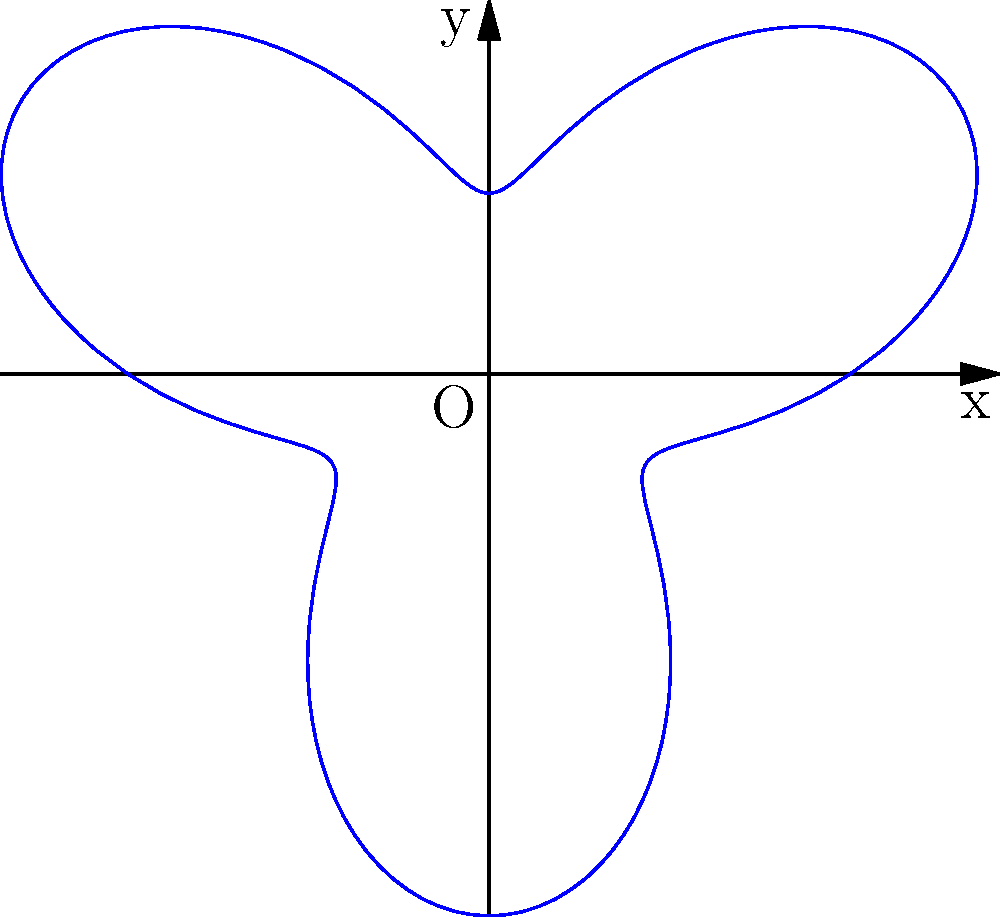A mime artist is creating an imaginary balloon with a unique shape. The outline of the balloon can be represented in polar coordinates by the equation $r = 2 + \sin(3\theta)$. What is the maximum radius of this balloon? To find the maximum radius of the balloon, we need to follow these steps:

1) The given equation is $r = 2 + \sin(3\theta)$

2) The maximum value of $r$ will occur when $\sin(3\theta)$ is at its maximum.

3) We know that the maximum value of sine function is 1.

4) Therefore, the maximum value of $r$ will be:

   $r_{max} = 2 + 1 = 3$

5) This occurs when $\sin(3\theta) = 1$, which happens when $3\theta = \frac{\pi}{2}, \frac{5\pi}{2}, \frac{9\pi}{2}$, etc.

   Or when $\theta = \frac{\pi}{6}, \frac{5\pi}{6}, \frac{3\pi}{2}$, etc.

Thus, the maximum radius of the balloon is 3 units.
Answer: 3 units 